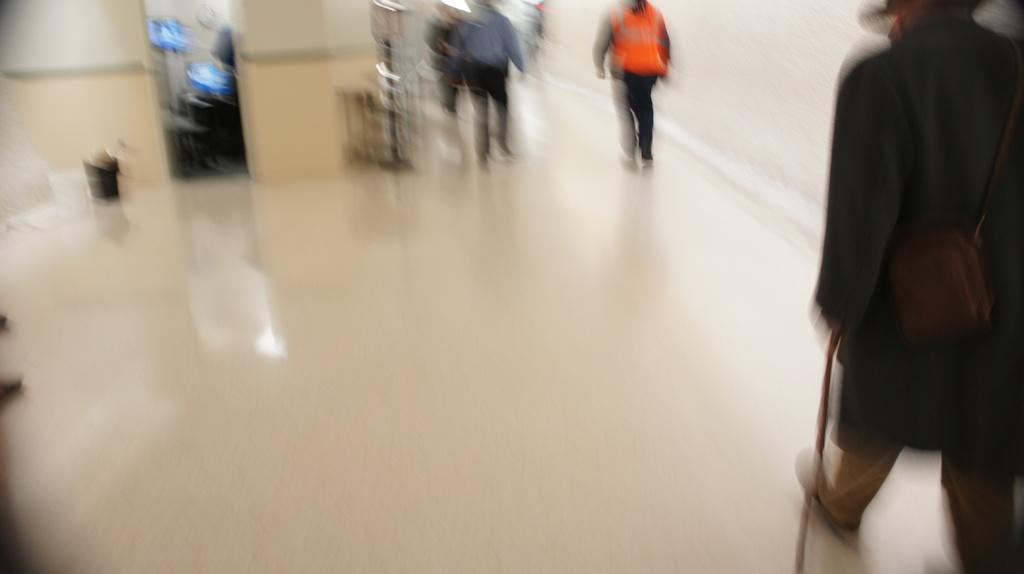How many people are in the image? The number of people in the image cannot be determined from the provided facts. What is the setting of the image? The people are in a room. What type of pie is being recited in verse by the people in the image? There is no pie or verse present in the image; it only shows people in a room. 